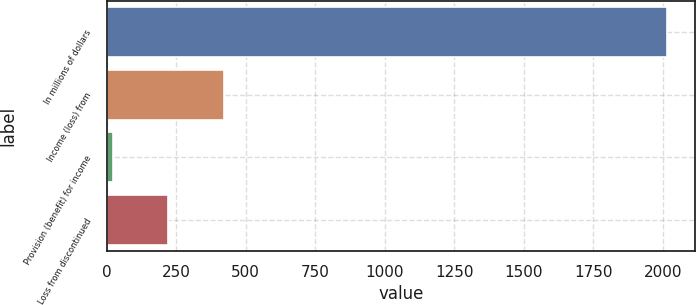Convert chart to OTSL. <chart><loc_0><loc_0><loc_500><loc_500><bar_chart><fcel>In millions of dollars<fcel>Income (loss) from<fcel>Provision (benefit) for income<fcel>Loss from discontinued<nl><fcel>2016<fcel>420.8<fcel>22<fcel>221.4<nl></chart> 